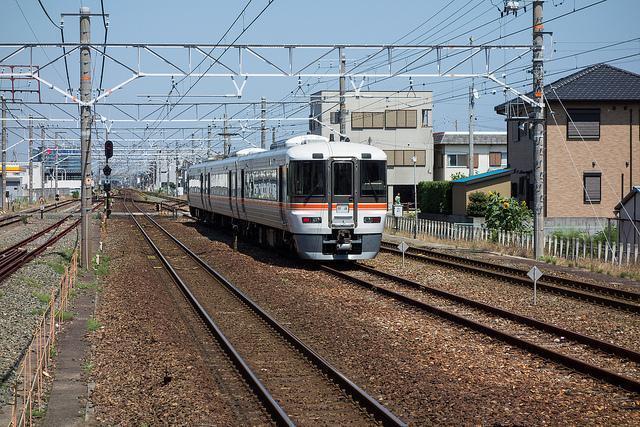How many men are standing in the bed of the truck?
Give a very brief answer. 0. 